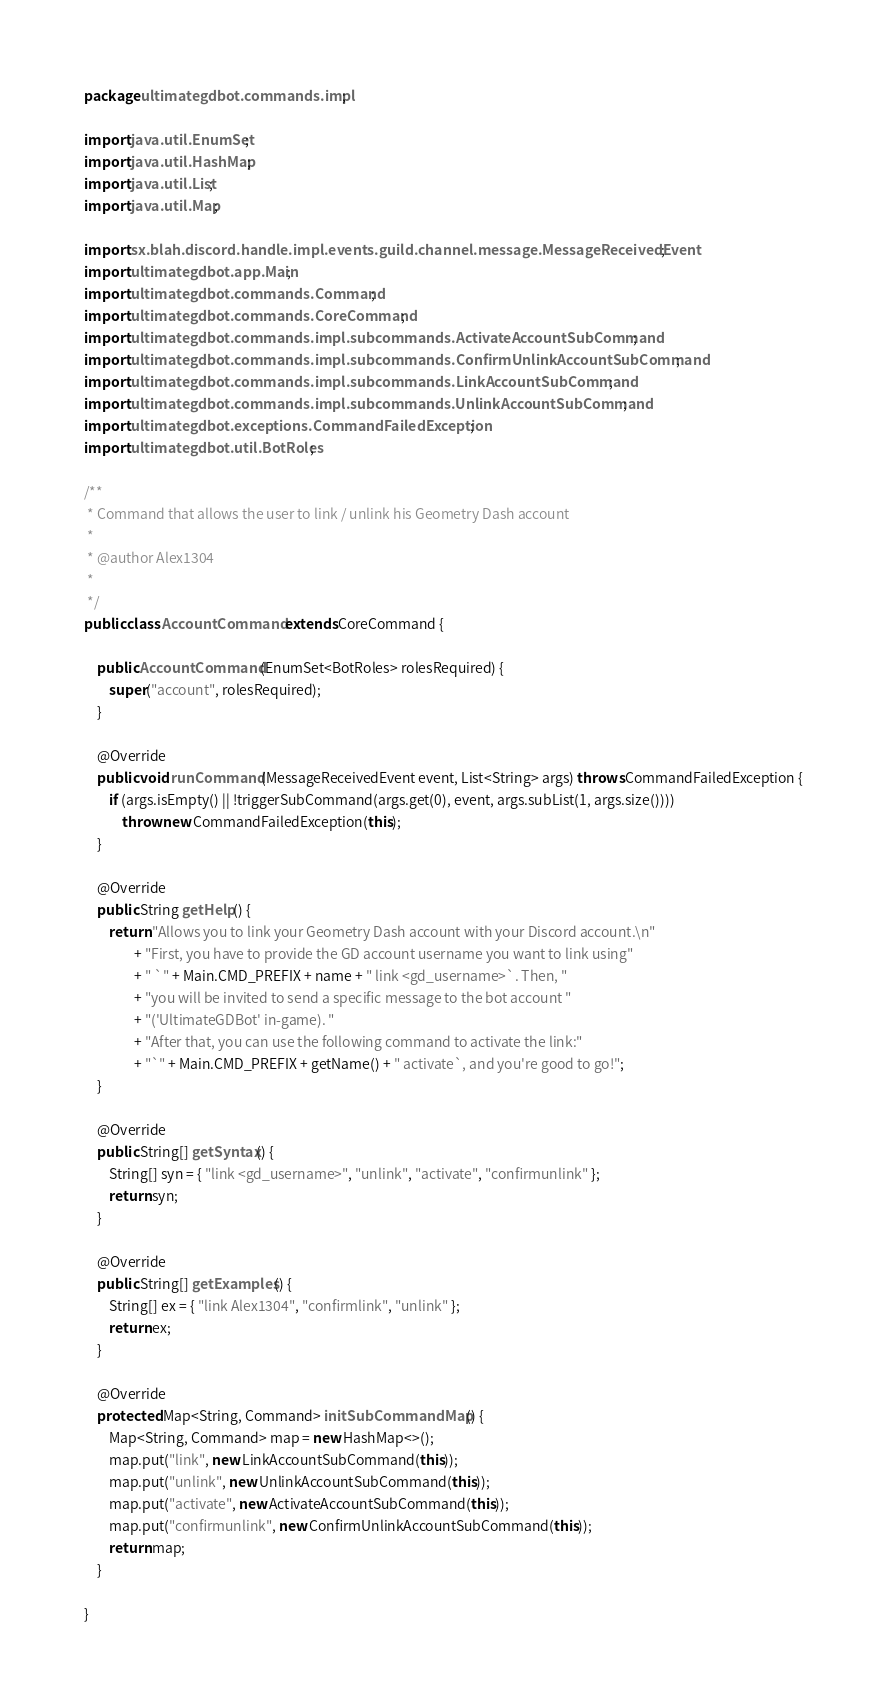Convert code to text. <code><loc_0><loc_0><loc_500><loc_500><_Java_>package ultimategdbot.commands.impl;

import java.util.EnumSet;
import java.util.HashMap;
import java.util.List;
import java.util.Map;

import sx.blah.discord.handle.impl.events.guild.channel.message.MessageReceivedEvent;
import ultimategdbot.app.Main;
import ultimategdbot.commands.Command;
import ultimategdbot.commands.CoreCommand;
import ultimategdbot.commands.impl.subcommands.ActivateAccountSubCommand;
import ultimategdbot.commands.impl.subcommands.ConfirmUnlinkAccountSubCommand;
import ultimategdbot.commands.impl.subcommands.LinkAccountSubCommand;
import ultimategdbot.commands.impl.subcommands.UnlinkAccountSubCommand;
import ultimategdbot.exceptions.CommandFailedException;
import ultimategdbot.util.BotRoles;

/**
 * Command that allows the user to link / unlink his Geometry Dash account
 * 
 * @author Alex1304
 *
 */
public class AccountCommand extends CoreCommand {

	public AccountCommand(EnumSet<BotRoles> rolesRequired) {
		super("account", rolesRequired);
	}

	@Override
	public void runCommand(MessageReceivedEvent event, List<String> args) throws CommandFailedException {
		if (args.isEmpty() || !triggerSubCommand(args.get(0), event, args.subList(1, args.size())))
			throw new CommandFailedException(this);
	}

	@Override
	public String getHelp() {
		return "Allows you to link your Geometry Dash account with your Discord account.\n"
				+ "First, you have to provide the GD account username you want to link using"
				+ " `" + Main.CMD_PREFIX + name + " link <gd_username>`. Then, "
				+ "you will be invited to send a specific message to the bot account "
				+ "('UltimateGDBot' in-game). "
				+ "After that, you can use the following command to activate the link:"
				+ "`" + Main.CMD_PREFIX + getName() + " activate`, and you're good to go!";
	}

	@Override
	public String[] getSyntax() {
		String[] syn = { "link <gd_username>", "unlink", "activate", "confirmunlink" };
		return syn;
	}

	@Override
	public String[] getExamples() {
		String[] ex = { "link Alex1304", "confirmlink", "unlink" };
		return ex;
	}

	@Override
	protected Map<String, Command> initSubCommandMap() {
		Map<String, Command> map = new HashMap<>();
		map.put("link", new LinkAccountSubCommand(this));
		map.put("unlink", new UnlinkAccountSubCommand(this));
		map.put("activate", new ActivateAccountSubCommand(this));
		map.put("confirmunlink", new ConfirmUnlinkAccountSubCommand(this));
		return map;
	}

}
</code> 